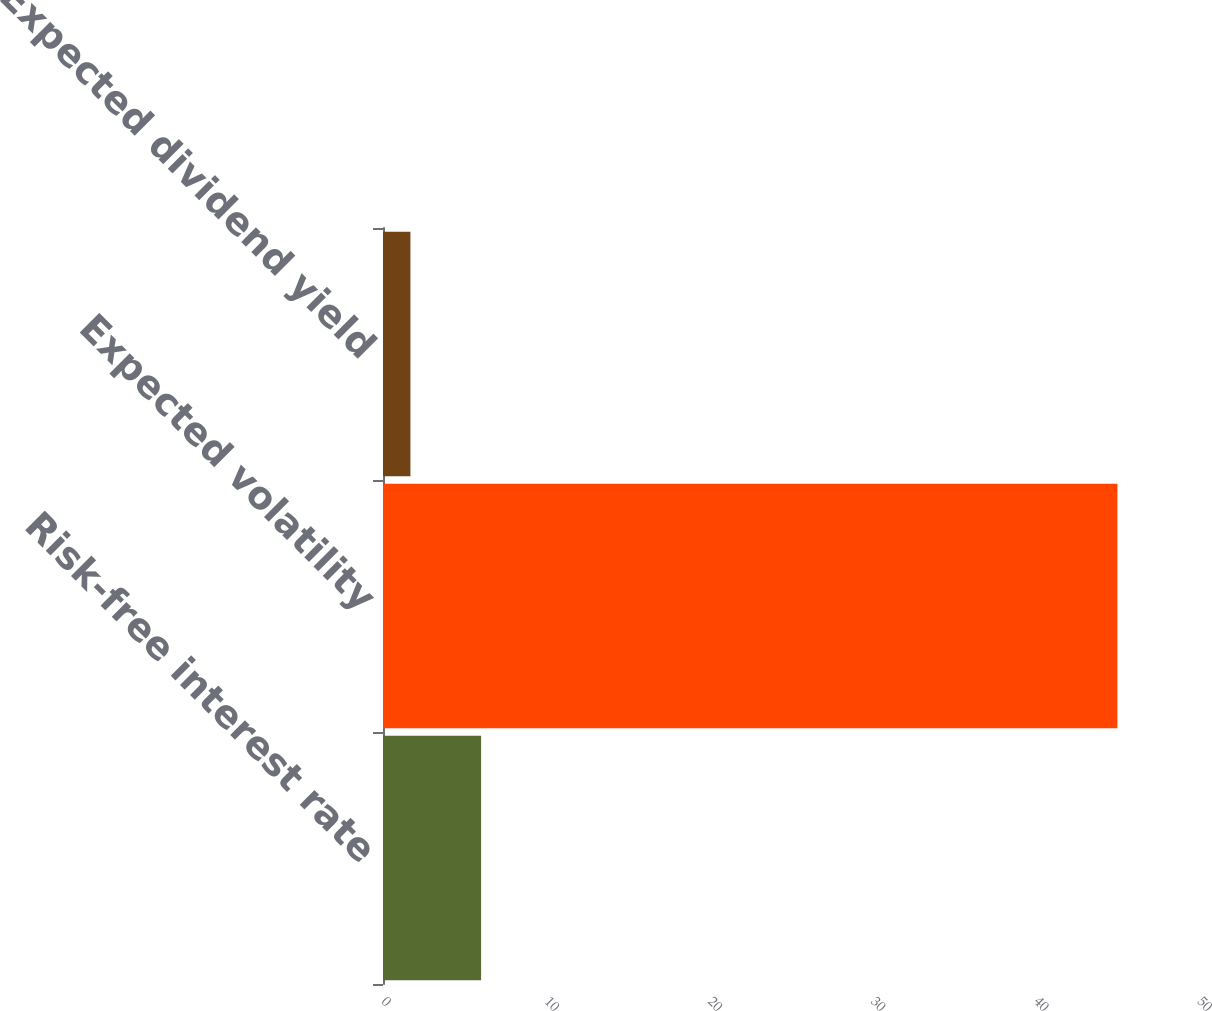Convert chart. <chart><loc_0><loc_0><loc_500><loc_500><bar_chart><fcel>Risk-free interest rate<fcel>Expected volatility<fcel>Expected dividend yield<nl><fcel>6.01<fcel>45<fcel>1.68<nl></chart> 